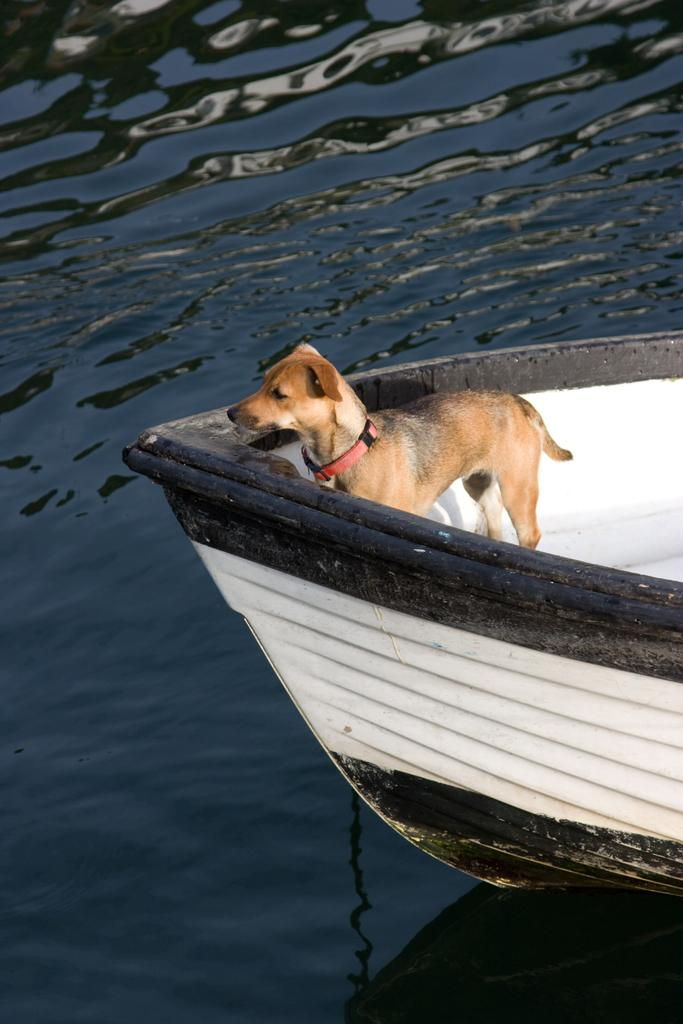What animal is present in the image? There is a dog in the image. Where is the dog located? The dog is in a boat. What is the boat situated on? The boat is on the water. What type of doctor is treating the tiger in the image? There is no doctor or tiger present in the image; it features a dog in a boat on the water. 